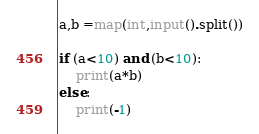Convert code to text. <code><loc_0><loc_0><loc_500><loc_500><_Python_>a,b =map(int,input().split())

if (a<10) and (b<10):
    print(a*b)
else:
    print(-1)</code> 